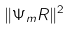Convert formula to latex. <formula><loc_0><loc_0><loc_500><loc_500>\| \Psi _ { m } R \| ^ { 2 }</formula> 